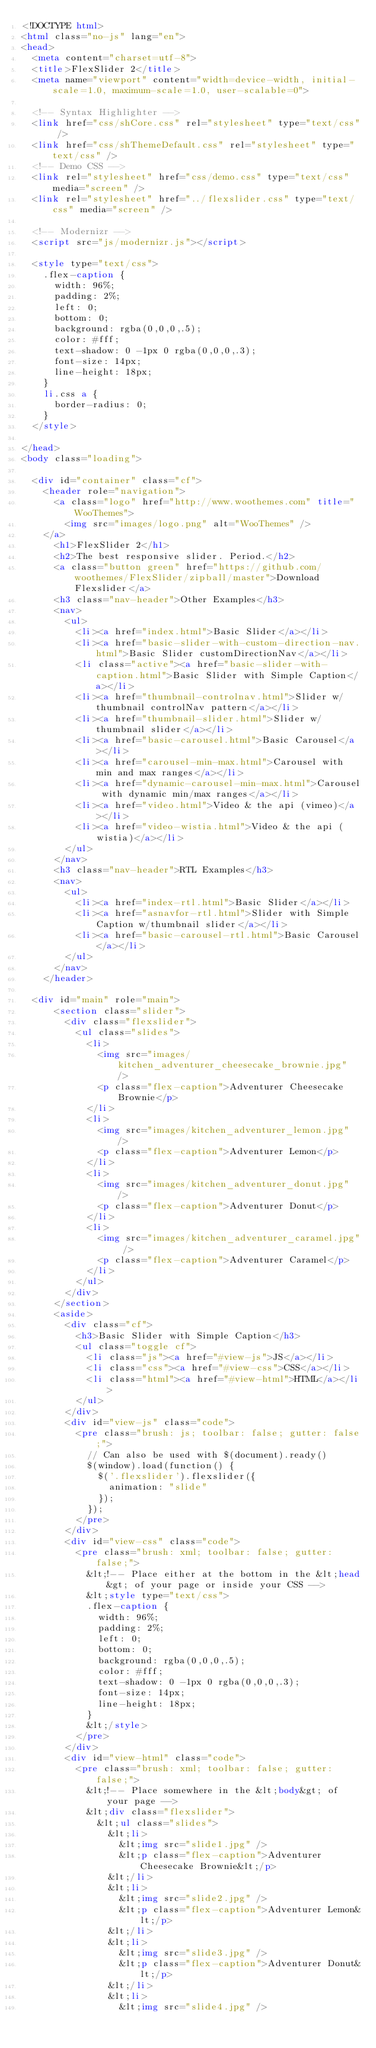<code> <loc_0><loc_0><loc_500><loc_500><_HTML_><!DOCTYPE html>
<html class="no-js" lang="en">
<head>
	<meta content="charset=utf-8">
	<title>FlexSlider 2</title>
	<meta name="viewport" content="width=device-width, initial-scale=1.0, maximum-scale=1.0, user-scalable=0">

  <!-- Syntax Highlighter -->
  <link href="css/shCore.css" rel="stylesheet" type="text/css" />
  <link href="css/shThemeDefault.css" rel="stylesheet" type="text/css" />
  <!-- Demo CSS -->
	<link rel="stylesheet" href="css/demo.css" type="text/css" media="screen" />
	<link rel="stylesheet" href="../flexslider.css" type="text/css" media="screen" />

	<!-- Modernizr -->
  <script src="js/modernizr.js"></script>

  <style type="text/css">
    .flex-caption {
      width: 96%;
      padding: 2%;
      left: 0;
      bottom: 0;
      background: rgba(0,0,0,.5);
      color: #fff;
      text-shadow: 0 -1px 0 rgba(0,0,0,.3);
      font-size: 14px;
      line-height: 18px;
    }
    li.css a {
      border-radius: 0;
    }
  </style>

</head>
<body class="loading">

  <div id="container" class="cf">
    <header role="navigation">
      <a class="logo" href="http://www.woothemes.com" title="WooThemes">
        <img src="images/logo.png" alt="WooThemes" />
	  </a>
      <h1>FlexSlider 2</h1>
      <h2>The best responsive slider. Period.</h2>
      <a class="button green" href="https://github.com/woothemes/FlexSlider/zipball/master">Download Flexslider</a>
      <h3 class="nav-header">Other Examples</h3>
      <nav>
        <ul>
          <li><a href="index.html">Basic Slider</a></li>
          <li><a href="basic-slider-with-custom-direction-nav.html">Basic Slider customDirectionNav</a></li>
          <li class="active"><a href="basic-slider-with-caption.html">Basic Slider with Simple Caption</a></li>
          <li><a href="thumbnail-controlnav.html">Slider w/thumbnail controlNav pattern</a></li>
          <li><a href="thumbnail-slider.html">Slider w/thumbnail slider</a></li>
          <li><a href="basic-carousel.html">Basic Carousel</a></li>
          <li><a href="carousel-min-max.html">Carousel with min and max ranges</a></li>
          <li><a href="dynamic-carousel-min-max.html">Carousel with dynamic min/max ranges</a></li>
          <li><a href="video.html">Video & the api (vimeo)</a></li>
          <li><a href="video-wistia.html">Video & the api (wistia)</a></li>
        </ul>
      </nav>
      <h3 class="nav-header">RTL Examples</h3>
      <nav>
        <ul>
          <li><a href="index-rtl.html">Basic Slider</a></li>
          <li><a href="asnavfor-rtl.html">Slider with Simple Caption w/thumbnail slider</a></li>
          <li><a href="basic-carousel-rtl.html">Basic Carousel</a></li>
        </ul>
      </nav>
    </header>

	<div id="main" role="main">
      <section class="slider">
        <div class="flexslider">
          <ul class="slides">
            <li>
  	    	    <img src="images/kitchen_adventurer_cheesecake_brownie.jpg" />
              <p class="flex-caption">Adventurer Cheesecake Brownie</p>
  	    		</li>
  	    		<li>
  	    	    <img src="images/kitchen_adventurer_lemon.jpg" />
              <p class="flex-caption">Adventurer Lemon</p>
  	    		</li>
  	    		<li>
  	    	    <img src="images/kitchen_adventurer_donut.jpg" />
              <p class="flex-caption">Adventurer Donut</p>
  	    		</li>
  	    		<li>
  	    	    <img src="images/kitchen_adventurer_caramel.jpg" />
              <p class="flex-caption">Adventurer Caramel</p>
  	    		</li>
          </ul>
        </div>
      </section>
      <aside>
        <div class="cf">
          <h3>Basic Slider with Simple Caption</h3>
          <ul class="toggle cf">
            <li class="js"><a href="#view-js">JS</a></li>
            <li class="css"><a href="#view-css">CSS</a></li>
            <li class="html"><a href="#view-html">HTML</a></li>
          </ul>
        </div>
        <div id="view-js" class="code">
          <pre class="brush: js; toolbar: false; gutter: false;">
            // Can also be used with $(document).ready()
            $(window).load(function() {
              $('.flexslider').flexslider({
                animation: "slide"
              });
            });
          </pre>
        </div>
        <div id="view-css" class="code">
          <pre class="brush: xml; toolbar: false; gutter: false;">
            &lt;!-- Place either at the bottom in the &lt;head&gt; of your page or inside your CSS -->
            &lt;style type="text/css">
            .flex-caption {
              width: 96%;
              padding: 2%;
              left: 0;
              bottom: 0;
              background: rgba(0,0,0,.5);
              color: #fff;
              text-shadow: 0 -1px 0 rgba(0,0,0,.3);
              font-size: 14px;
              line-height: 18px;
            }
            &lt;/style>
          </pre>
        </div>
        <div id="view-html" class="code">
          <pre class="brush: xml; toolbar: false; gutter: false;">
            &lt;!-- Place somewhere in the &lt;body&gt; of your page -->
            &lt;div class="flexslider">
              &lt;ul class="slides">
                &lt;li>
                  &lt;img src="slide1.jpg" />
                  &lt;p class="flex-caption">Adventurer Cheesecake Brownie&lt;/p>
                &lt;/li>
                &lt;li>
                  &lt;img src="slide2.jpg" />
                  &lt;p class="flex-caption">Adventurer Lemon&lt;/p>
                &lt;/li>
                &lt;li>
                  &lt;img src="slide3.jpg" />
                  &lt;p class="flex-caption">Adventurer Donut&lt;/p>
                &lt;/li>
                &lt;li>
                  &lt;img src="slide4.jpg" /></code> 